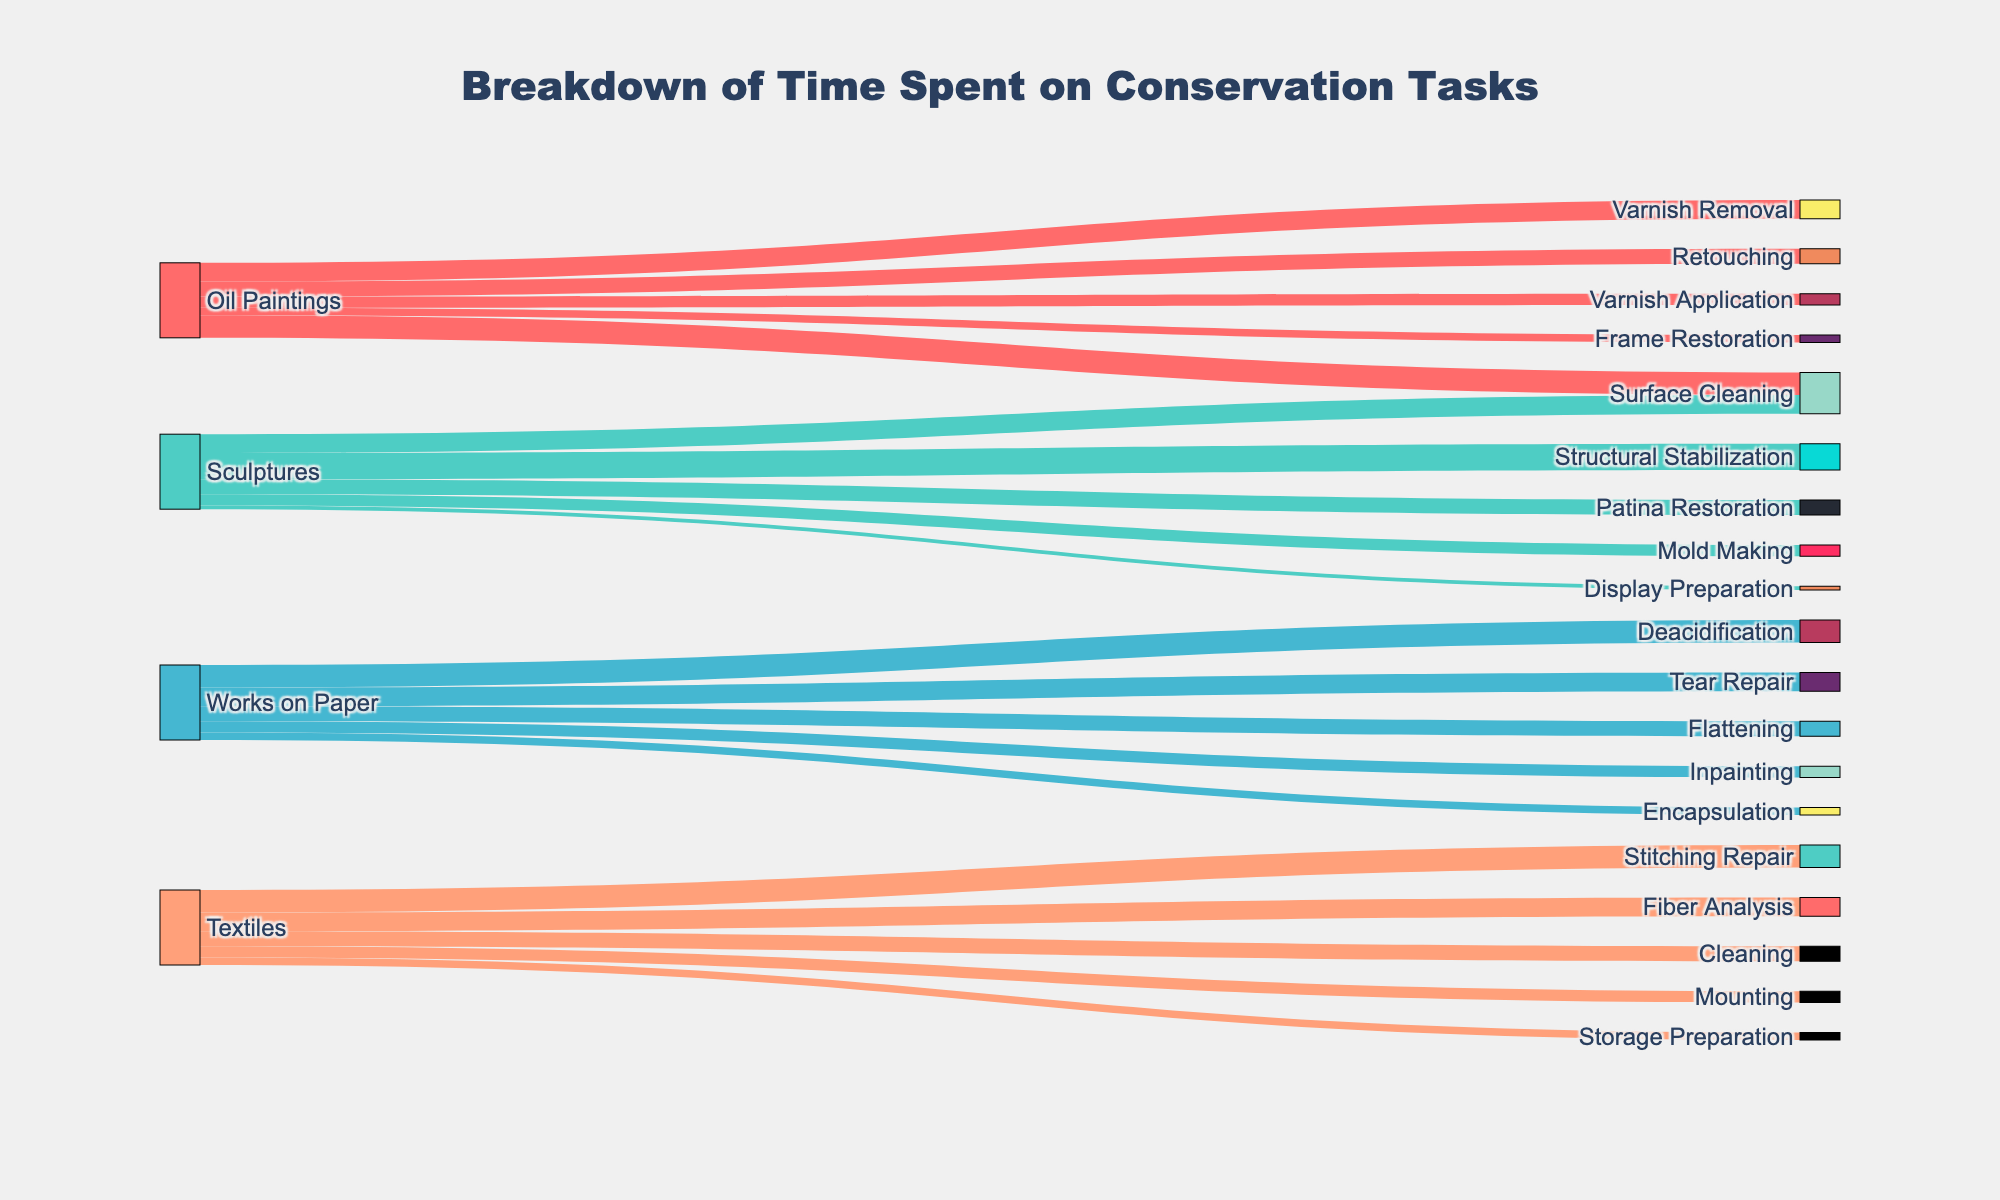What's the title of the figure? The title of a figure is usually located at the top and provides a brief description of what the figure is about. In this case, the title "Breakdown of Time Spent on Conservation Tasks" clearly describes the content.
Answer: Breakdown of Time Spent on Conservation Tasks Which task has the highest time spent for Oil Paintings? By examining the connections between "Oil Paintings" and its subsequent tasks, we can see that "Surface Cleaning" has the largest flow, indicating the highest time spent.
Answer: Surface Cleaning What is the total time spent on conservation tasks for Sculptures? Adding up all the values for tasks associated with "Sculptures" (35 + 25 + 20 + 15 + 5), we get 100.
Answer: 100 Which artwork type has the least different tasks listed? By counting the number of unique tasks for each artwork type: Oil Paintings (5), Sculptures (5), Works on Paper (5), and Textiles (5). All have the same number of tasks listed.
Answer: All have the same number What is the total time allocated to Surface Cleaning across all artworks? Surface Cleaning appears for Oil Paintings (30) and Sculptures (25). Adding these values gives a total time of 30 + 25 = 55.
Answer: 55 Which artwork type has the highest overall time spent on a single task? By examining the tasks for each artwork type:
- Oil Paintings: Surface Cleaning (30)
- Sculptures: Structural Stabilization (35)
- Works on Paper: Deacidification (30)
- Textiles: Stitching Repair (30)
Sculptures' Structural Stabilization has the highest value (35).
Answer: Sculptures (Structural Stabilization) How much more time is spent on Retouching Oil Paintings than Inpainting Works on Paper? Retouching Oil Paintings is 20, and Inpainting Works on Paper is 15. The difference is 20 - 15 = 5.
Answer: 5 Which task for Textiles has the highest value? By examining the tasks associated with Textiles, Stitching Repair has the highest value at 30.
Answer: Stitching Repair What is the relationship between the time allocated for Varnish Application and Frame Restoration for Oil Paintings? Varnish Application has a value of 15, and Frame Restoration has a value of 10. Varnish Application has more time allocated.
Answer: Varnish Application has more time Which two tasks have an equal amount of time allocated and what is that amount? By examining the times, Deacidification for Works on Paper and Surface Cleaning for Oil Paintings both have a value of 30.
Answer: Deacidification and Surface Cleaning, 30 